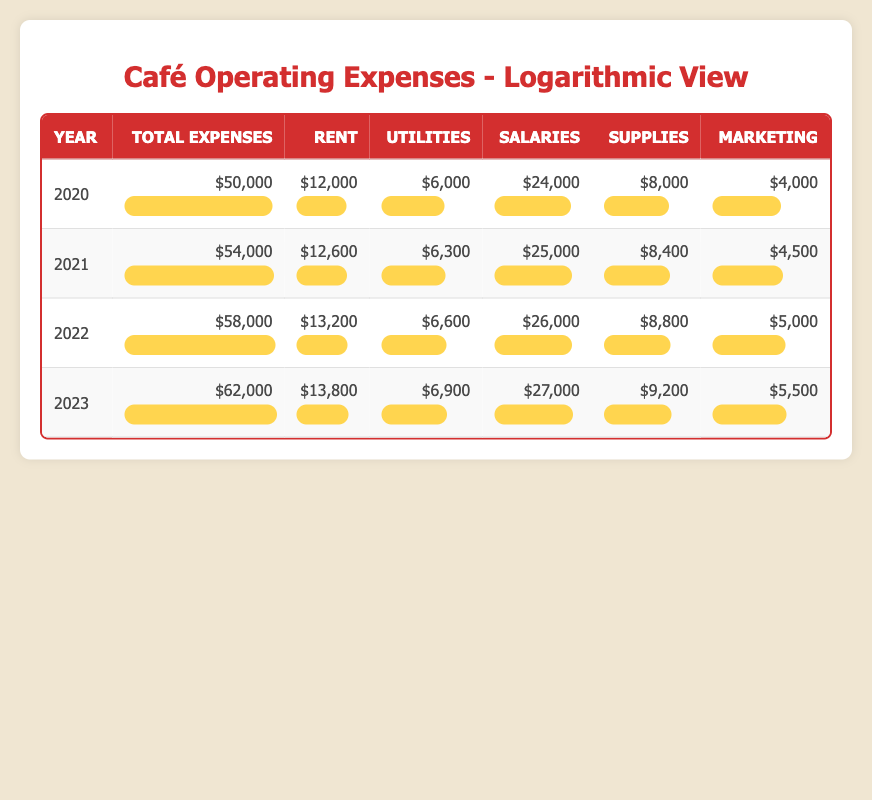What were the total expenses in 2021? The total expenses for 2021 are listed in the table as $54,000.
Answer: $54,000 What was the highest expense category in 2023? In 2023, the highest expense category is salaries, which amount to $27,000.
Answer: Salaries What is the average operating expense per year from 2020 to 2023? To find the average, sum the total expenses from each year: 50000 + 54000 + 58000 + 62000 = 224000. Then divide by 4 (the number of years): 224000 / 4 = 56000.
Answer: $56,000 Did the total expenses decrease from 2020 to 2021? No, the table shows that total expenses increased from $50,000 in 2020 to $54,000 in 2021.
Answer: No What was the increase in salaries from 2022 to 2023? To find the increase in salaries, subtract the salary amount of 2022 from that of 2023: 27000 - 26000 = 1000.
Answer: $1,000 Which year had the lowest operating expenses? According to the table, 2020 had the lowest operating expenses at $50,000.
Answer: 2020 Is the rent expense consistently increasing each year? Yes, the rent expense increased every year, from $12,000 in 2020 to $13,800 in 2023.
Answer: Yes What is the percentage increase in marketing expenses from 2020 to 2023? The marketing expense in 2020 was $4,000 and in 2023 it was $5,500. The increase is 5500 - 4000 = 1500. The percentage increase is (1500 / 4000) * 100 = 37.5%.
Answer: 37.5% 